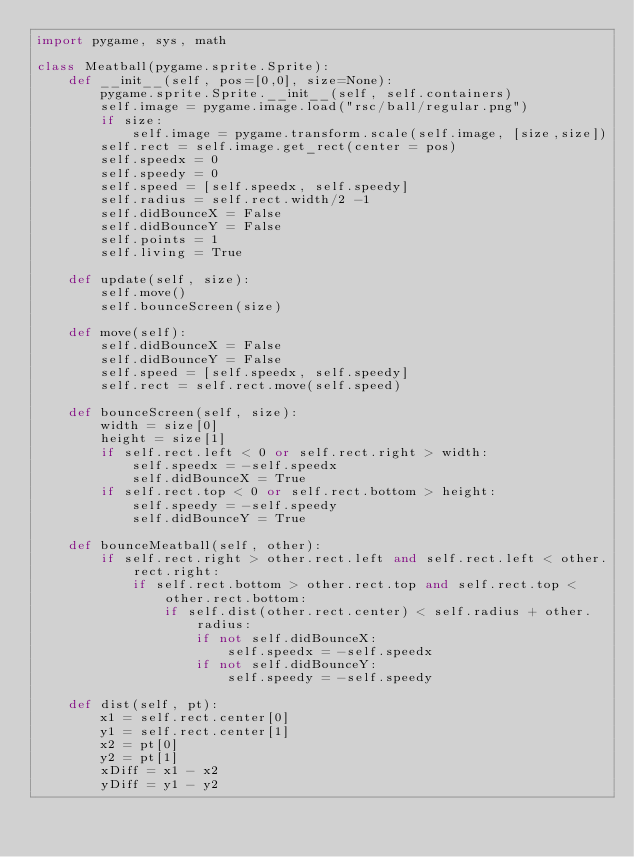Convert code to text. <code><loc_0><loc_0><loc_500><loc_500><_Python_>import pygame, sys, math

class Meatball(pygame.sprite.Sprite):
    def __init__(self, pos=[0,0], size=None):
        pygame.sprite.Sprite.__init__(self, self.containers)
        self.image = pygame.image.load("rsc/ball/regular.png")
        if size:
            self.image = pygame.transform.scale(self.image, [size,size])
        self.rect = self.image.get_rect(center = pos)
        self.speedx = 0
        self.speedy = 0
        self.speed = [self.speedx, self.speedy]
        self.radius = self.rect.width/2 -1
        self.didBounceX = False
        self.didBounceY = False
        self.points = 1
        self.living = True

    def update(self, size):
        self.move()
        self.bounceScreen(size)
    
    def move(self):
        self.didBounceX = False
        self.didBounceY = False
        self.speed = [self.speedx, self.speedy]
        self.rect = self.rect.move(self.speed)
        
    def bounceScreen(self, size):
        width = size[0]
        height = size[1]
        if self.rect.left < 0 or self.rect.right > width:
            self.speedx = -self.speedx
            self.didBounceX = True
        if self.rect.top < 0 or self.rect.bottom > height:
            self.speedy = -self.speedy
            self.didBounceY = True
            
    def bounceMeatball(self, other):
        if self.rect.right > other.rect.left and self.rect.left < other.rect.right:
            if self.rect.bottom > other.rect.top and self.rect.top < other.rect.bottom:
                if self.dist(other.rect.center) < self.radius + other.radius:
                    if not self.didBounceX:
                        self.speedx = -self.speedx
                    if not self.didBounceY:
                        self.speedy = -self.speedy
        
    def dist(self, pt):
        x1 = self.rect.center[0]
        y1 = self.rect.center[1]
        x2 = pt[0]
        y2 = pt[1]
        xDiff = x1 - x2
        yDiff = y1 - y2</code> 